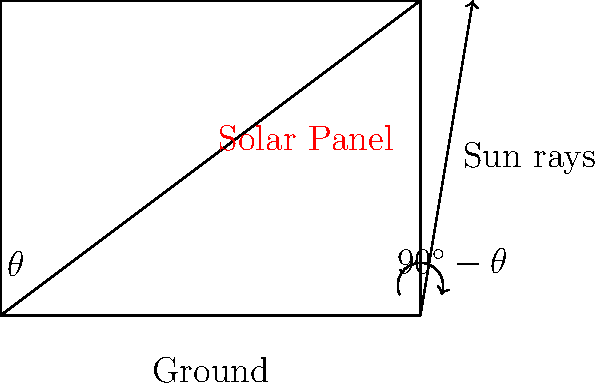As a sustainability-conscious sales manager, you're considering installing solar panels on your office building. Given that the optimal angle for a solar panel is typically equal to the latitude of the location, how would you determine this angle if your office is located at 37°N latitude? Use the diagram to explain your reasoning. To determine the optimal angle for a solar panel, we can follow these steps:

1. Recall that the optimal angle for a solar panel is generally equal to the latitude of the location.

2. In this case, the office is located at 37°N latitude.

3. Looking at the diagram:
   - The ground is represented by the horizontal line.
   - The solar panel is shown as the angled line.
   - The angle $\theta$ represents the tilt of the solar panel from the horizontal.

4. For optimal performance, we want the solar panel to be perpendicular to the sun's rays when the sun is at its highest point (solar noon).

5. At solar noon, the sun's angle above the horizon is complementary to the latitude. This means:
   $\text{Sun's angle} = 90^\circ - \text{Latitude}$

6. To make the panel perpendicular to the sun's rays, its tilt should be:
   $\theta = \text{Latitude} = 90^\circ - \text{Sun's angle}$

7. Therefore, the optimal tilt angle $\theta$ for the solar panel should be equal to the latitude, which is 37°.

This angle ensures that the solar panel receives the maximum amount of direct sunlight throughout the year, optimizing energy production for your office building.
Answer: 37° 